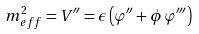<formula> <loc_0><loc_0><loc_500><loc_500>m _ { e f f } ^ { 2 } = V ^ { \prime \prime } = \epsilon \left ( \varphi ^ { \prime \prime } + \phi \, \varphi ^ { \prime \prime \prime } \right )</formula> 